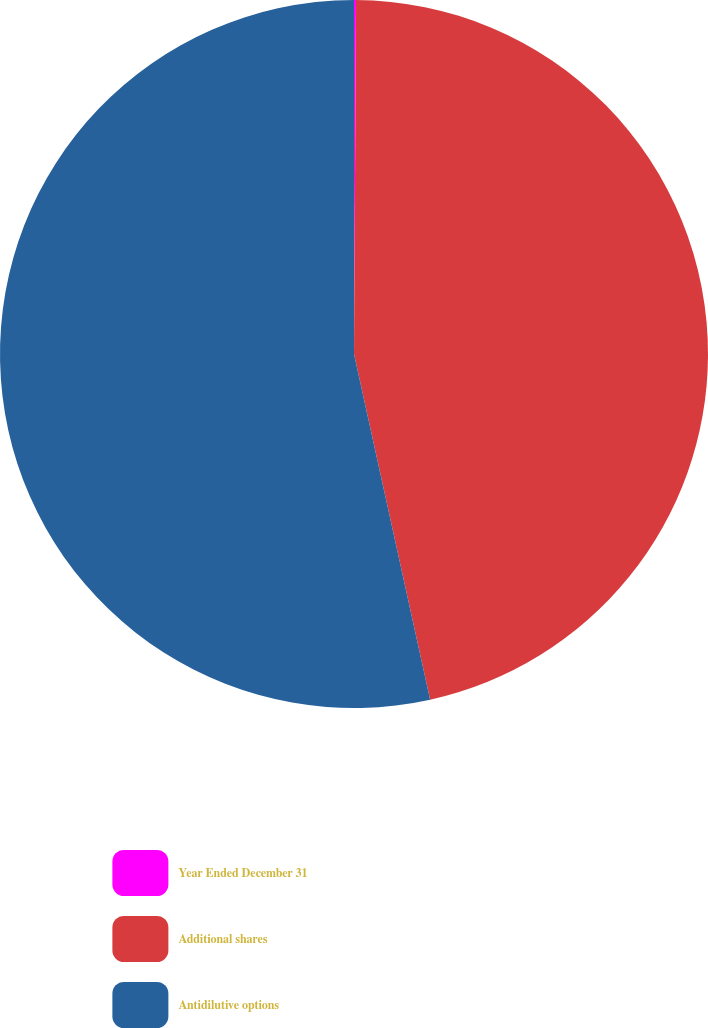Convert chart to OTSL. <chart><loc_0><loc_0><loc_500><loc_500><pie_chart><fcel>Year Ended December 31<fcel>Additional shares<fcel>Antidilutive options<nl><fcel>0.09%<fcel>46.46%<fcel>53.45%<nl></chart> 